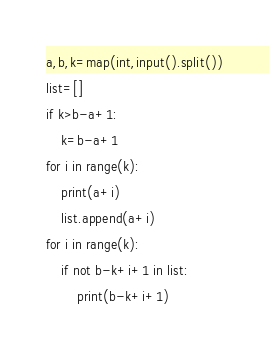Convert code to text. <code><loc_0><loc_0><loc_500><loc_500><_Python_>a,b,k=map(int,input().split())
list=[]
if k>b-a+1:
    k=b-a+1
for i in range(k):
    print(a+i)
    list.append(a+i)
for i in range(k):
    if not b-k+i+1 in list:
        print(b-k+i+1)</code> 